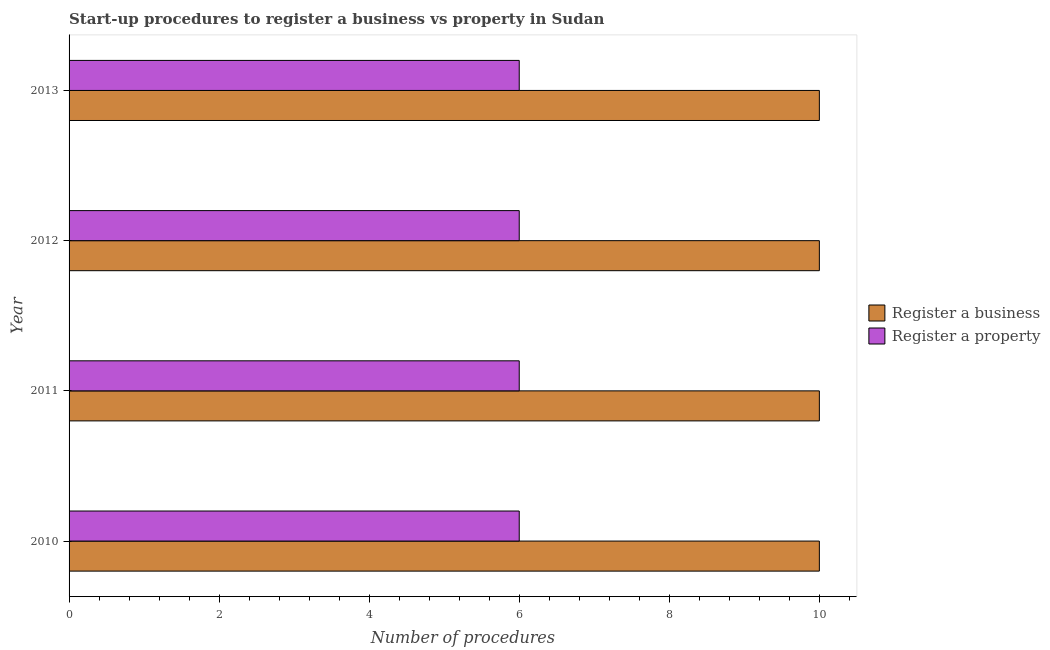How many groups of bars are there?
Provide a short and direct response. 4. Are the number of bars per tick equal to the number of legend labels?
Make the answer very short. Yes. Are the number of bars on each tick of the Y-axis equal?
Make the answer very short. Yes. How many bars are there on the 1st tick from the top?
Make the answer very short. 2. What is the label of the 1st group of bars from the top?
Your answer should be compact. 2013. What is the number of procedures to register a property in 2012?
Offer a terse response. 6. Across all years, what is the maximum number of procedures to register a business?
Offer a very short reply. 10. In which year was the number of procedures to register a business maximum?
Ensure brevity in your answer.  2010. What is the total number of procedures to register a business in the graph?
Offer a very short reply. 40. What is the difference between the number of procedures to register a property in 2011 and that in 2012?
Give a very brief answer. 0. What is the difference between the number of procedures to register a business in 2012 and the number of procedures to register a property in 2011?
Offer a terse response. 4. What is the average number of procedures to register a property per year?
Your answer should be very brief. 6. In the year 2011, what is the difference between the number of procedures to register a property and number of procedures to register a business?
Offer a terse response. -4. In how many years, is the number of procedures to register a business greater than 5.2 ?
Your answer should be compact. 4. What is the ratio of the number of procedures to register a property in 2010 to that in 2011?
Provide a short and direct response. 1. In how many years, is the number of procedures to register a property greater than the average number of procedures to register a property taken over all years?
Provide a succinct answer. 0. Is the sum of the number of procedures to register a property in 2010 and 2013 greater than the maximum number of procedures to register a business across all years?
Provide a succinct answer. Yes. What does the 2nd bar from the top in 2012 represents?
Provide a succinct answer. Register a business. What does the 2nd bar from the bottom in 2012 represents?
Ensure brevity in your answer.  Register a property. Are the values on the major ticks of X-axis written in scientific E-notation?
Provide a short and direct response. No. Does the graph contain any zero values?
Keep it short and to the point. No. Does the graph contain grids?
Give a very brief answer. No. How many legend labels are there?
Make the answer very short. 2. How are the legend labels stacked?
Your answer should be compact. Vertical. What is the title of the graph?
Your answer should be compact. Start-up procedures to register a business vs property in Sudan. What is the label or title of the X-axis?
Offer a very short reply. Number of procedures. What is the Number of procedures of Register a property in 2011?
Your answer should be very brief. 6. What is the Number of procedures of Register a property in 2013?
Offer a terse response. 6. Across all years, what is the maximum Number of procedures of Register a business?
Your response must be concise. 10. Across all years, what is the maximum Number of procedures in Register a property?
Provide a succinct answer. 6. Across all years, what is the minimum Number of procedures in Register a business?
Provide a succinct answer. 10. Across all years, what is the minimum Number of procedures of Register a property?
Ensure brevity in your answer.  6. What is the total Number of procedures of Register a business in the graph?
Offer a very short reply. 40. What is the total Number of procedures in Register a property in the graph?
Your response must be concise. 24. What is the difference between the Number of procedures of Register a property in 2010 and that in 2012?
Provide a short and direct response. 0. What is the difference between the Number of procedures of Register a property in 2010 and that in 2013?
Offer a terse response. 0. What is the difference between the Number of procedures of Register a business in 2012 and that in 2013?
Ensure brevity in your answer.  0. What is the difference between the Number of procedures in Register a property in 2012 and that in 2013?
Provide a short and direct response. 0. What is the difference between the Number of procedures in Register a business in 2010 and the Number of procedures in Register a property in 2013?
Your answer should be compact. 4. What is the difference between the Number of procedures in Register a business in 2011 and the Number of procedures in Register a property in 2012?
Give a very brief answer. 4. What is the difference between the Number of procedures in Register a business in 2011 and the Number of procedures in Register a property in 2013?
Offer a terse response. 4. What is the difference between the Number of procedures in Register a business in 2012 and the Number of procedures in Register a property in 2013?
Make the answer very short. 4. What is the average Number of procedures in Register a business per year?
Give a very brief answer. 10. In the year 2011, what is the difference between the Number of procedures of Register a business and Number of procedures of Register a property?
Give a very brief answer. 4. In the year 2012, what is the difference between the Number of procedures in Register a business and Number of procedures in Register a property?
Give a very brief answer. 4. What is the ratio of the Number of procedures of Register a property in 2010 to that in 2012?
Ensure brevity in your answer.  1. What is the ratio of the Number of procedures of Register a property in 2010 to that in 2013?
Give a very brief answer. 1. What is the ratio of the Number of procedures of Register a business in 2011 to that in 2012?
Your answer should be very brief. 1. What is the ratio of the Number of procedures of Register a property in 2011 to that in 2012?
Provide a short and direct response. 1. What is the ratio of the Number of procedures in Register a business in 2012 to that in 2013?
Your response must be concise. 1. What is the ratio of the Number of procedures of Register a property in 2012 to that in 2013?
Make the answer very short. 1. What is the difference between the highest and the lowest Number of procedures of Register a business?
Offer a terse response. 0. 